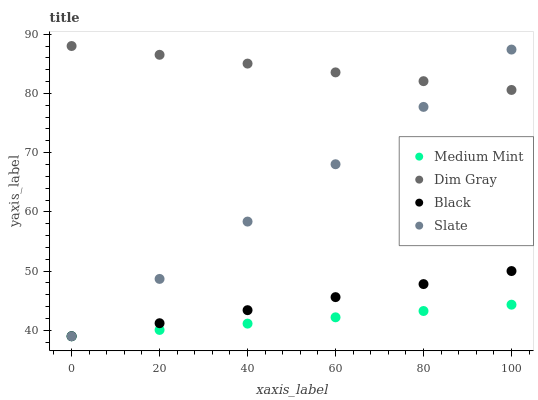Does Medium Mint have the minimum area under the curve?
Answer yes or no. Yes. Does Dim Gray have the maximum area under the curve?
Answer yes or no. Yes. Does Slate have the minimum area under the curve?
Answer yes or no. No. Does Slate have the maximum area under the curve?
Answer yes or no. No. Is Slate the smoothest?
Answer yes or no. Yes. Is Black the roughest?
Answer yes or no. Yes. Is Dim Gray the smoothest?
Answer yes or no. No. Is Dim Gray the roughest?
Answer yes or no. No. Does Medium Mint have the lowest value?
Answer yes or no. Yes. Does Dim Gray have the lowest value?
Answer yes or no. No. Does Dim Gray have the highest value?
Answer yes or no. Yes. Does Slate have the highest value?
Answer yes or no. No. Is Black less than Dim Gray?
Answer yes or no. Yes. Is Dim Gray greater than Black?
Answer yes or no. Yes. Does Medium Mint intersect Black?
Answer yes or no. Yes. Is Medium Mint less than Black?
Answer yes or no. No. Is Medium Mint greater than Black?
Answer yes or no. No. Does Black intersect Dim Gray?
Answer yes or no. No. 